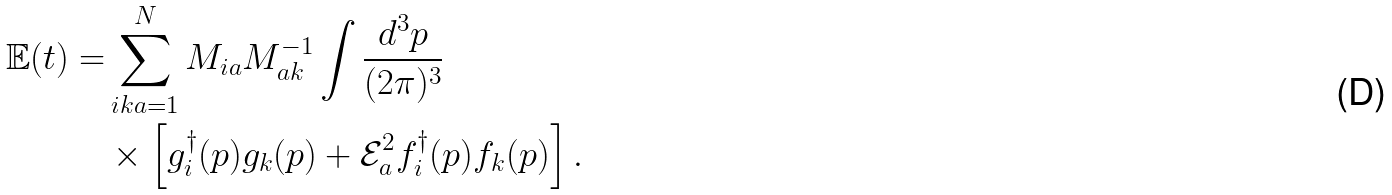<formula> <loc_0><loc_0><loc_500><loc_500>\mathbb { E } ( t ) = & \sum _ { i k a = 1 } ^ { N } M _ { i a } M ^ { - 1 } _ { a k } \int \frac { d ^ { 3 } p } { ( 2 \pi ) ^ { 3 } } \\ & \times \left [ g _ { i } ^ { \dag } ( p ) g _ { k } ( p ) + \mathcal { E } _ { a } ^ { 2 } f _ { i } ^ { \dag } ( p ) f _ { k } ( p ) \right ] .</formula> 